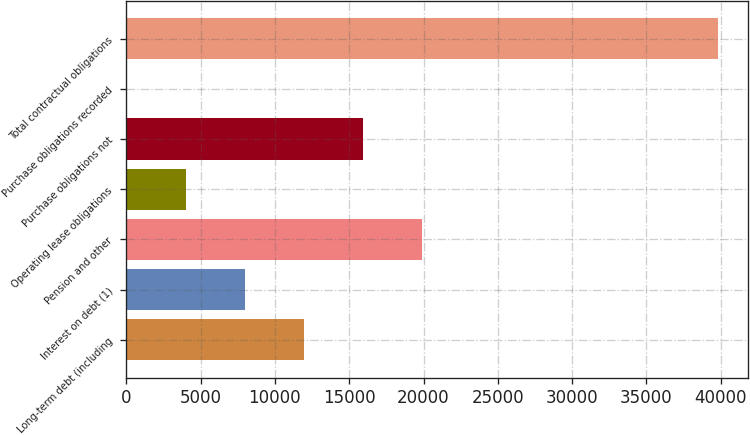<chart> <loc_0><loc_0><loc_500><loc_500><bar_chart><fcel>Long-term debt (including<fcel>Interest on debt (1)<fcel>Pension and other<fcel>Operating lease obligations<fcel>Purchase obligations not<fcel>Purchase obligations recorded<fcel>Total contractual obligations<nl><fcel>11952.9<fcel>7971.6<fcel>19915.5<fcel>3990.3<fcel>15934.2<fcel>9<fcel>39822<nl></chart> 